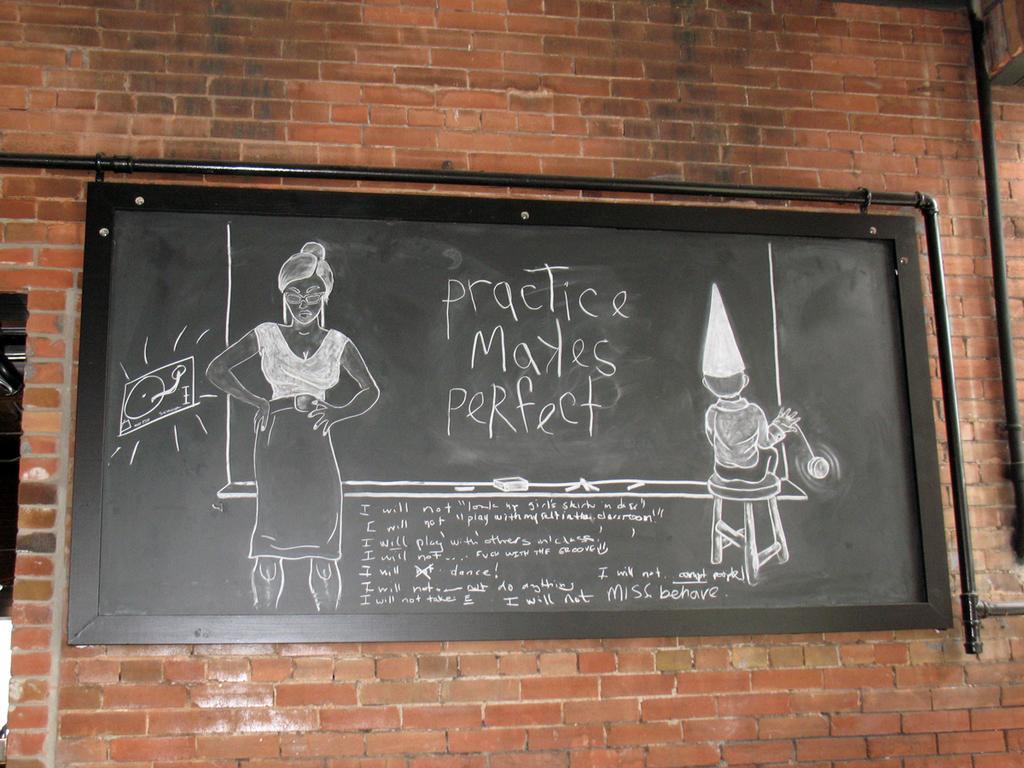How would you summarize this image in a sentence or two? In this picture there is a blackboard. There is a drawing on the blackboard. I can observe a drawing of a woman and a kid sitting on the stool. There is some text on the board. In the background I can observe a wall. 